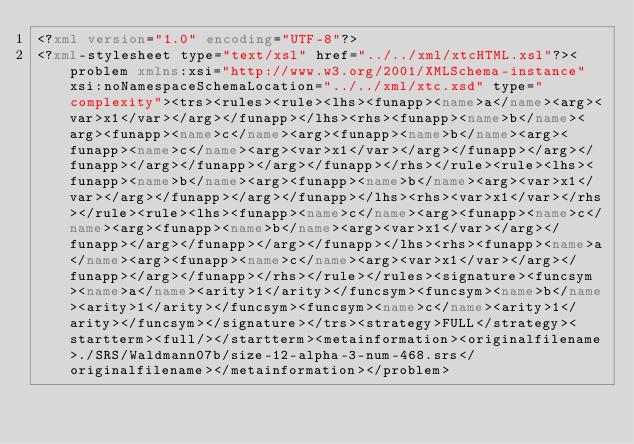Convert code to text. <code><loc_0><loc_0><loc_500><loc_500><_XML_><?xml version="1.0" encoding="UTF-8"?>
<?xml-stylesheet type="text/xsl" href="../../xml/xtcHTML.xsl"?><problem xmlns:xsi="http://www.w3.org/2001/XMLSchema-instance" xsi:noNamespaceSchemaLocation="../../xml/xtc.xsd" type="complexity"><trs><rules><rule><lhs><funapp><name>a</name><arg><var>x1</var></arg></funapp></lhs><rhs><funapp><name>b</name><arg><funapp><name>c</name><arg><funapp><name>b</name><arg><funapp><name>c</name><arg><var>x1</var></arg></funapp></arg></funapp></arg></funapp></arg></funapp></rhs></rule><rule><lhs><funapp><name>b</name><arg><funapp><name>b</name><arg><var>x1</var></arg></funapp></arg></funapp></lhs><rhs><var>x1</var></rhs></rule><rule><lhs><funapp><name>c</name><arg><funapp><name>c</name><arg><funapp><name>b</name><arg><var>x1</var></arg></funapp></arg></funapp></arg></funapp></lhs><rhs><funapp><name>a</name><arg><funapp><name>c</name><arg><var>x1</var></arg></funapp></arg></funapp></rhs></rule></rules><signature><funcsym><name>a</name><arity>1</arity></funcsym><funcsym><name>b</name><arity>1</arity></funcsym><funcsym><name>c</name><arity>1</arity></funcsym></signature></trs><strategy>FULL</strategy><startterm><full/></startterm><metainformation><originalfilename>./SRS/Waldmann07b/size-12-alpha-3-num-468.srs</originalfilename></metainformation></problem></code> 